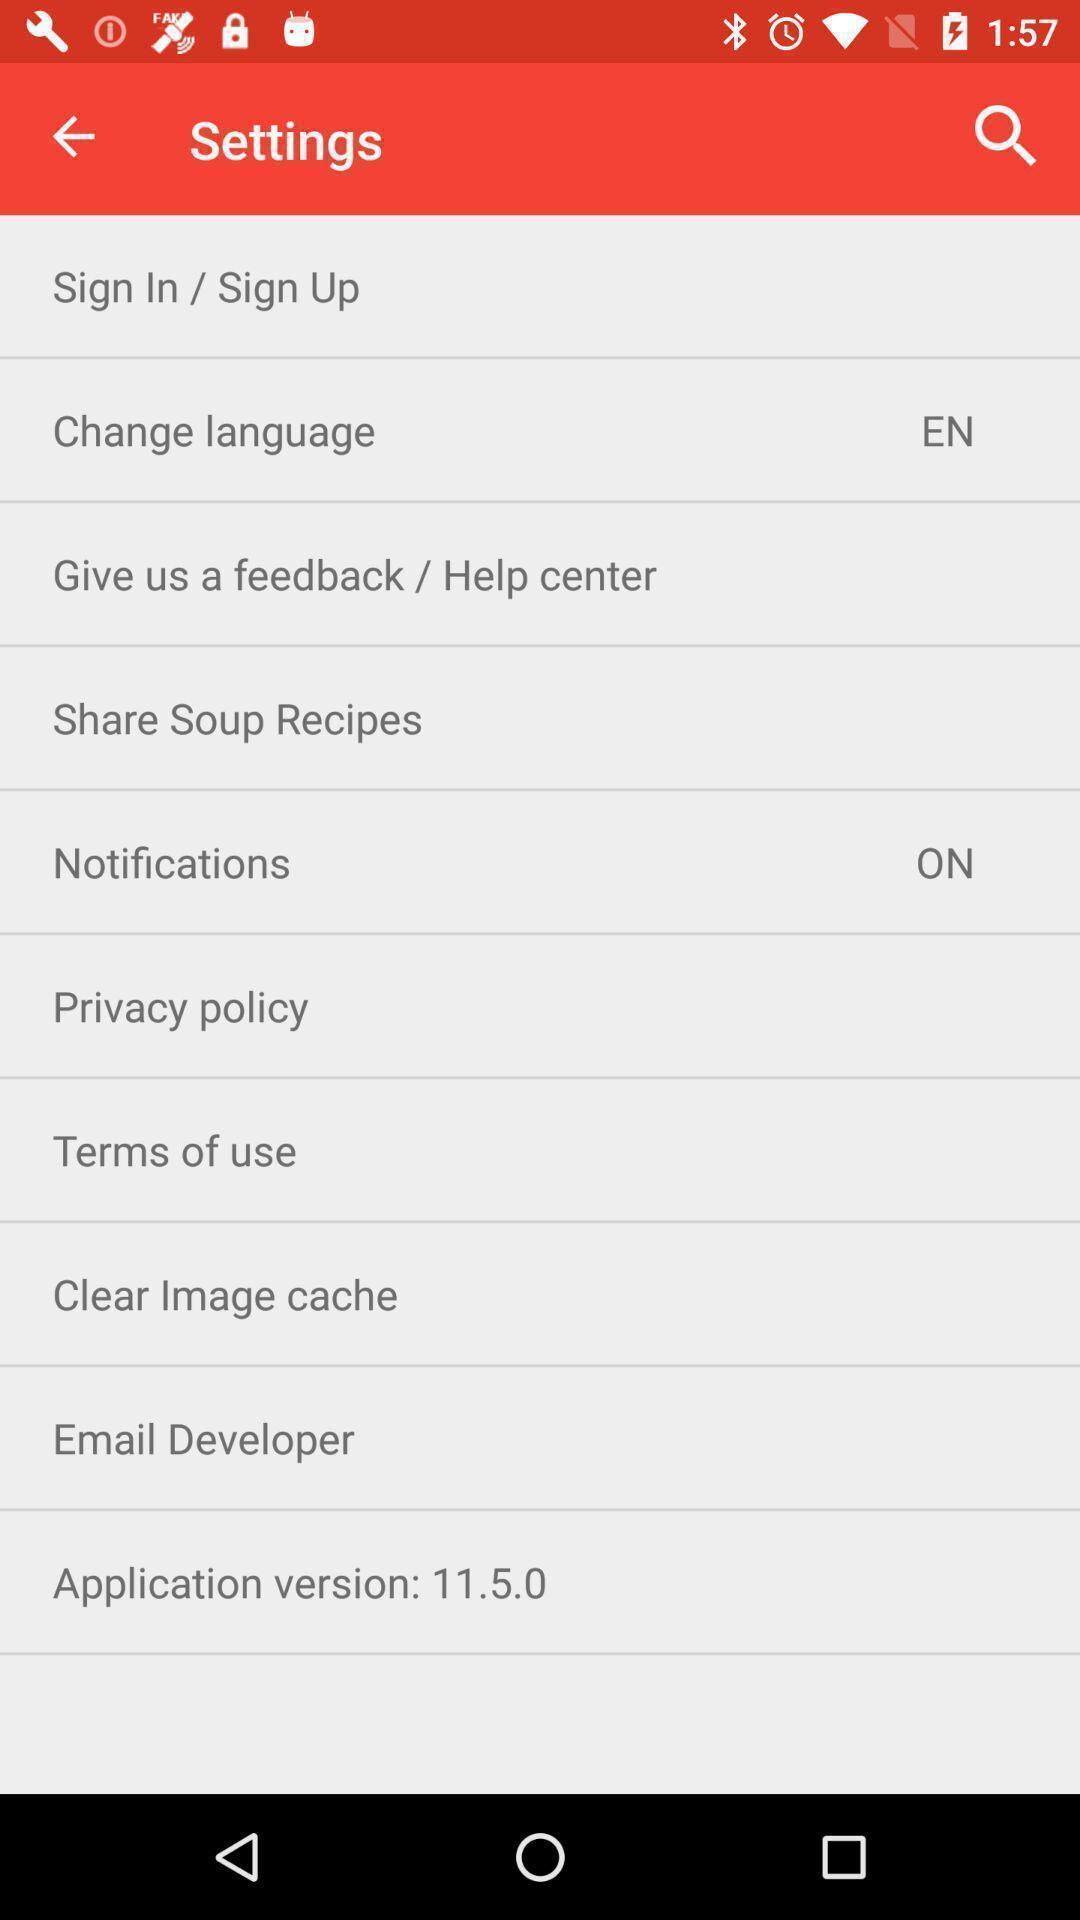Summarize the information in this screenshot. Settings page. 